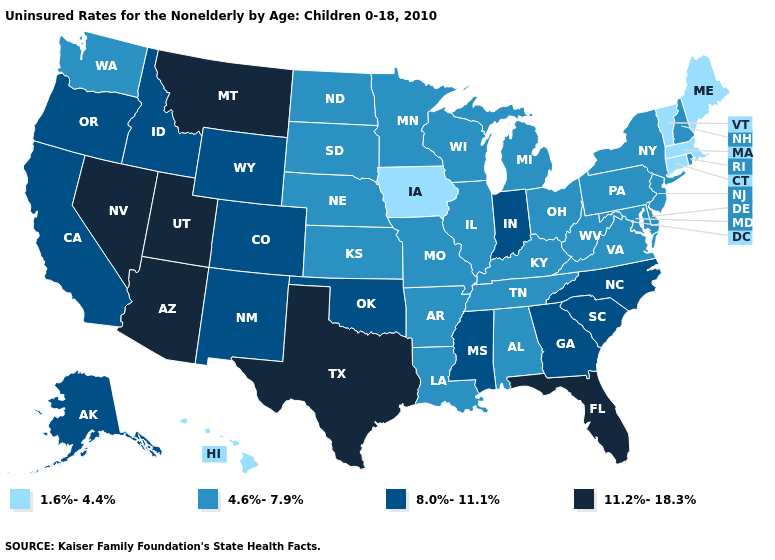What is the value of Nevada?
Give a very brief answer. 11.2%-18.3%. Does the first symbol in the legend represent the smallest category?
Be succinct. Yes. What is the value of Alabama?
Short answer required. 4.6%-7.9%. Name the states that have a value in the range 8.0%-11.1%?
Give a very brief answer. Alaska, California, Colorado, Georgia, Idaho, Indiana, Mississippi, New Mexico, North Carolina, Oklahoma, Oregon, South Carolina, Wyoming. Name the states that have a value in the range 1.6%-4.4%?
Give a very brief answer. Connecticut, Hawaii, Iowa, Maine, Massachusetts, Vermont. What is the highest value in the USA?
Short answer required. 11.2%-18.3%. Is the legend a continuous bar?
Quick response, please. No. Name the states that have a value in the range 11.2%-18.3%?
Answer briefly. Arizona, Florida, Montana, Nevada, Texas, Utah. Name the states that have a value in the range 1.6%-4.4%?
Keep it brief. Connecticut, Hawaii, Iowa, Maine, Massachusetts, Vermont. What is the highest value in the USA?
Answer briefly. 11.2%-18.3%. Name the states that have a value in the range 4.6%-7.9%?
Be succinct. Alabama, Arkansas, Delaware, Illinois, Kansas, Kentucky, Louisiana, Maryland, Michigan, Minnesota, Missouri, Nebraska, New Hampshire, New Jersey, New York, North Dakota, Ohio, Pennsylvania, Rhode Island, South Dakota, Tennessee, Virginia, Washington, West Virginia, Wisconsin. How many symbols are there in the legend?
Quick response, please. 4. Among the states that border Utah , which have the highest value?
Answer briefly. Arizona, Nevada. What is the value of Minnesota?
Keep it brief. 4.6%-7.9%. Among the states that border Nebraska , does Iowa have the lowest value?
Concise answer only. Yes. 